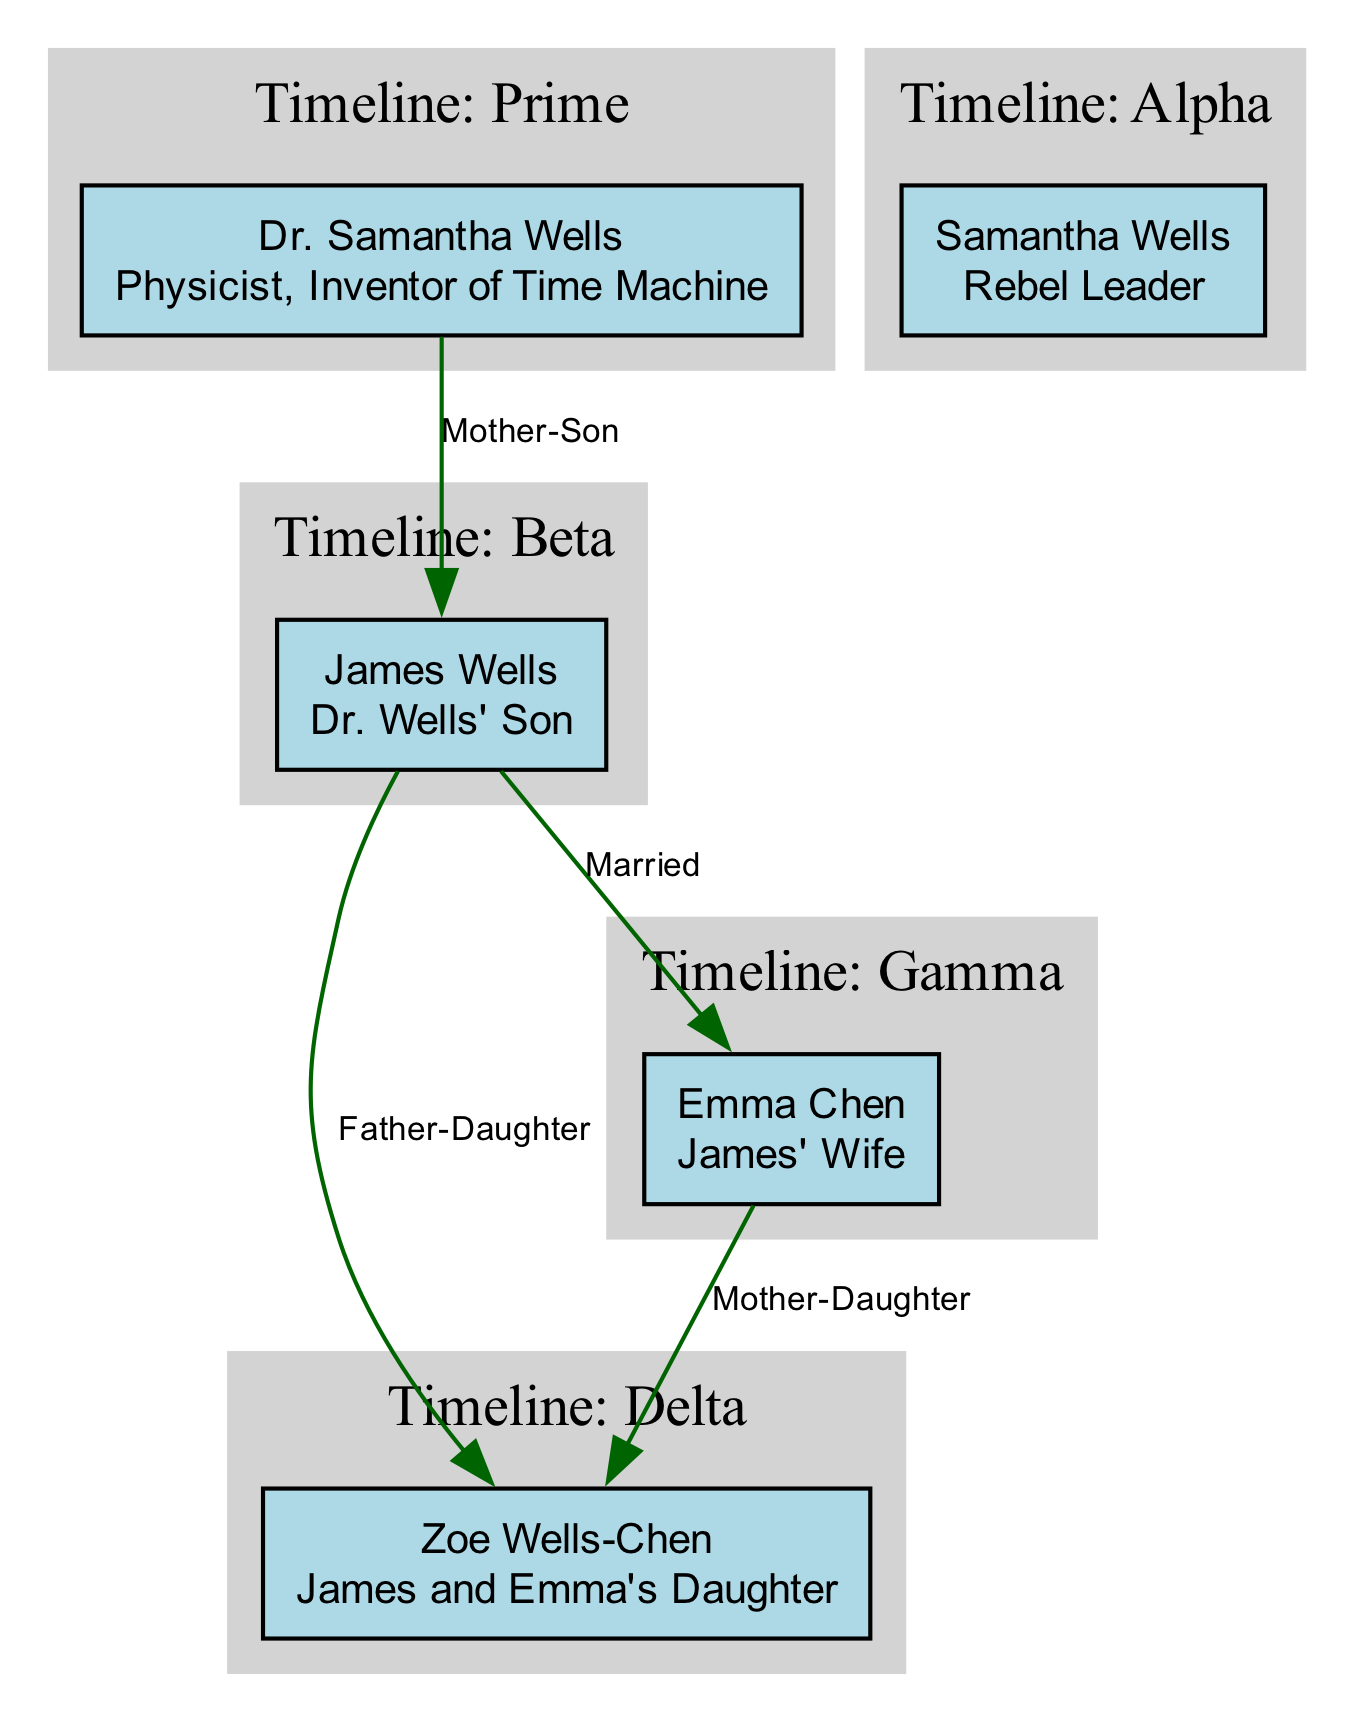What is the role of Dr. Samantha Wells? The diagram shows that Dr. Samantha Wells is labeled as "Physicist, Inventor of Time Machine" in the Prime timeline.
Answer: Physicist, Inventor of Time Machine How many characters are in the Alpha timeline? Upon reviewing the diagram, only one character, Samantha Wells, exists in the Alpha timeline.
Answer: 1 Who is James Wells' wife? The diagram connects James Wells with Emma Chen, indicating their marital relationship. Emma's role as "James' Wife" is also highlighted.
Answer: Emma Chen What is Zoe Wells-Chen's role in the Delta timeline? Zoe Wells-Chen is labeled as "Quantum Physicist" in the Delta timeline as per the diagram.
Answer: Quantum Physicist In which timeline does the character Emma Chen appear as a Time Pirate? The diagram indicates that Emma Chen appears as a Time Pirate in the Gamma timeline, as stated in her role description.
Answer: Gamma How many edges represent relationships in the diagram? By examining the diagram, it is clear that there are four edges that represent the relationships between the characters.
Answer: 4 Who is the father of Zoe Wells-Chen? The diagram shows that the relationship between James Wells and Zoe Wells-Chen is labeled as "Father-Daughter," confirming James Wells as Zoe's father.
Answer: James Wells Which character exists in both the Prime and Delta timelines? The diagram indicates that Zoe Wells-Chen exists in both the Prime timeline and the Delta timeline, as she is listed in both sections.
Answer: Zoe Wells-Chen What is the relationship between James Wells and Zoe Wells-Chen? The diagram states that James Wells has a "Father-Daughter" relationship with Zoe Wells-Chen, making this their connection clear.
Answer: Father-Daughter 